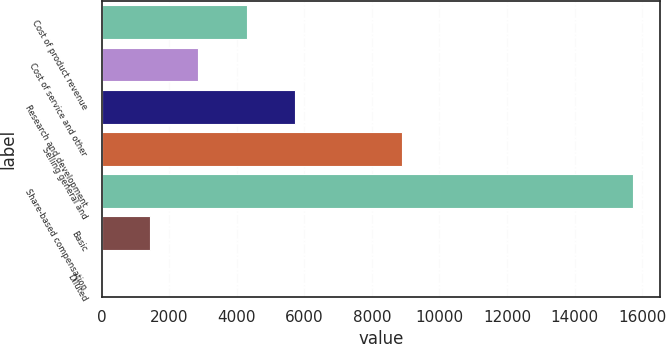Convert chart to OTSL. <chart><loc_0><loc_0><loc_500><loc_500><bar_chart><fcel>Cost of product revenue<fcel>Cost of service and other<fcel>Research and development<fcel>Selling general and<fcel>Share-based compensation<fcel>Basic<fcel>Diluted<nl><fcel>4291.32<fcel>2860.93<fcel>5721.7<fcel>8889<fcel>15734.4<fcel>1430.54<fcel>0.15<nl></chart> 